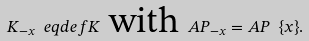Convert formula to latex. <formula><loc_0><loc_0><loc_500><loc_500>K _ { - x } \ e q d e f K \text { with } A P _ { - x } = A P \ \{ x \} .</formula> 